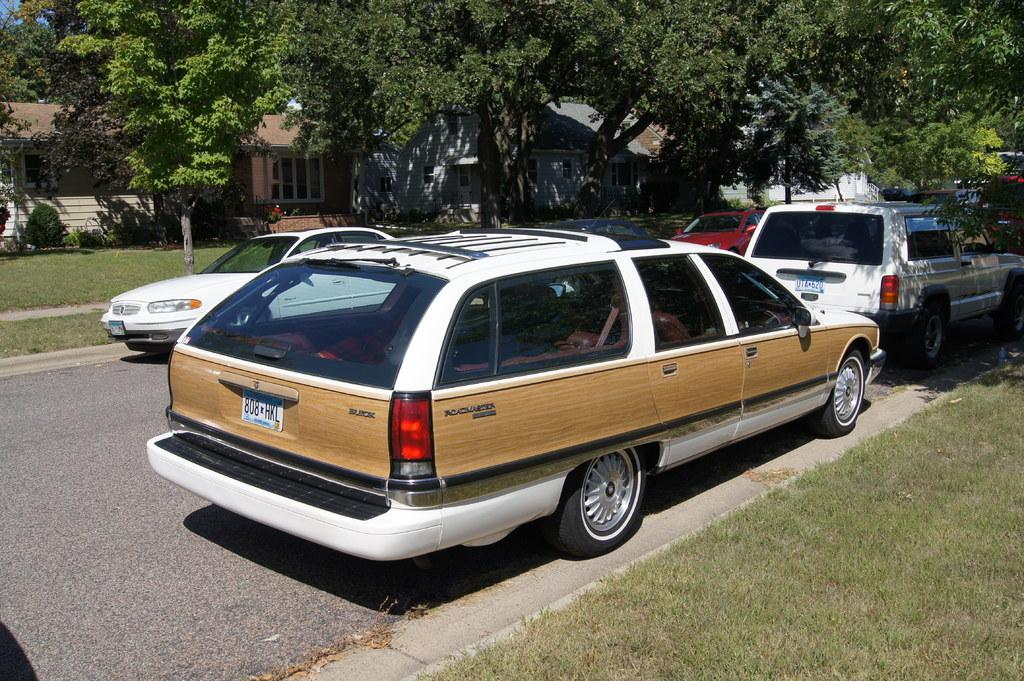<image>
Relay a brief, clear account of the picture shown. white station wagon with woodgrain siding and plates 808 HKL 